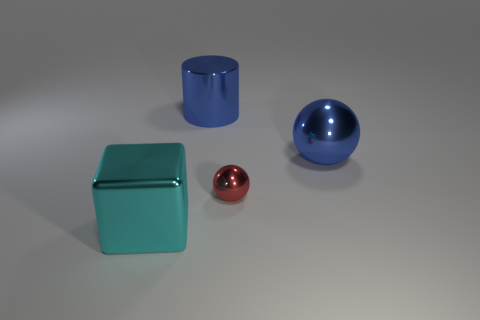How many other things are the same material as the cube?
Give a very brief answer. 3. What is the block made of?
Keep it short and to the point. Metal. How big is the blue thing that is left of the small ball?
Offer a terse response. Large. There is a big blue cylinder left of the small red ball; how many big metallic cylinders are to the left of it?
Your answer should be compact. 0. Does the object that is to the right of the red sphere have the same shape as the tiny red metallic object that is on the left side of the large blue metal ball?
Your response must be concise. Yes. How many blue shiny things are on the left side of the small thing and in front of the big blue cylinder?
Keep it short and to the point. 0. Are there any small metal objects that have the same color as the big shiny block?
Provide a succinct answer. No. There is a cyan metallic object that is the same size as the blue cylinder; what is its shape?
Your response must be concise. Cube. Are there any small red metallic things on the left side of the cyan metallic thing?
Your answer should be compact. No. What number of blue metal cylinders are the same size as the metallic cube?
Your answer should be compact. 1. 